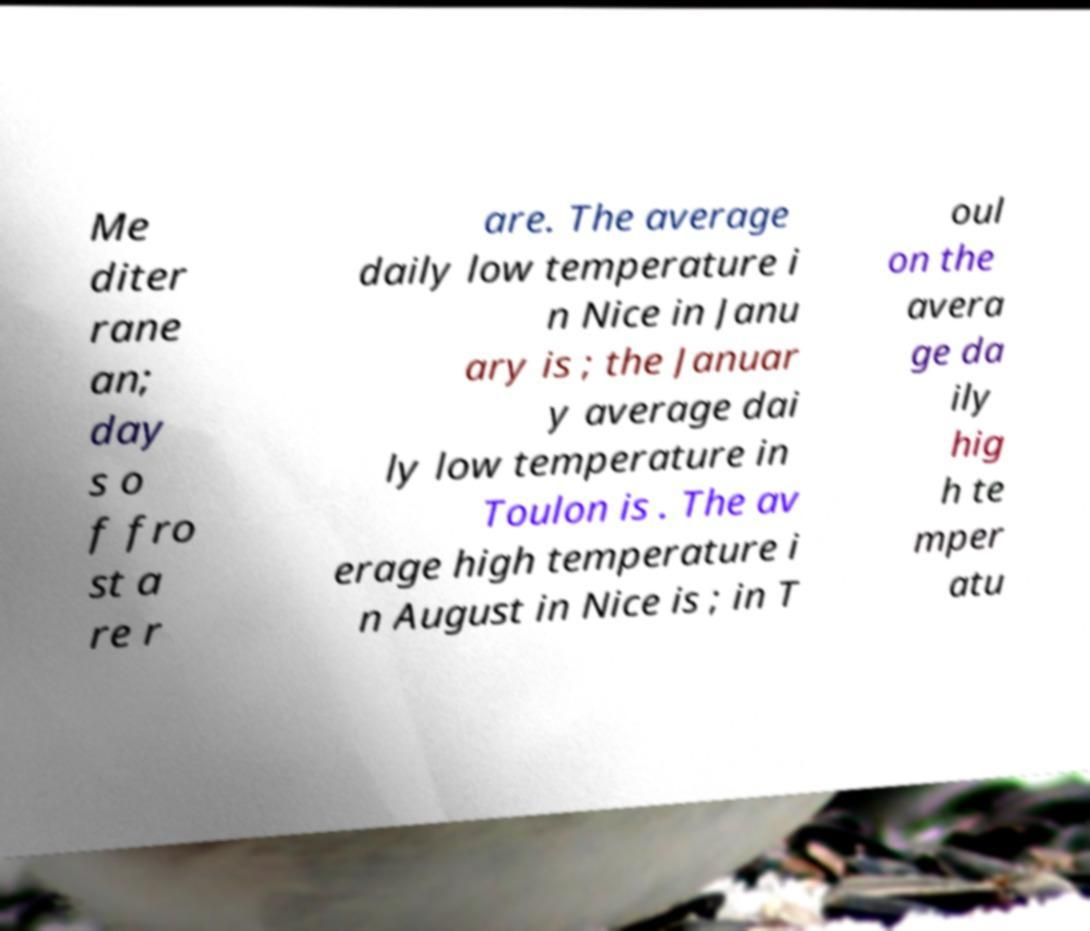What messages or text are displayed in this image? I need them in a readable, typed format. Me diter rane an; day s o f fro st a re r are. The average daily low temperature i n Nice in Janu ary is ; the Januar y average dai ly low temperature in Toulon is . The av erage high temperature i n August in Nice is ; in T oul on the avera ge da ily hig h te mper atu 